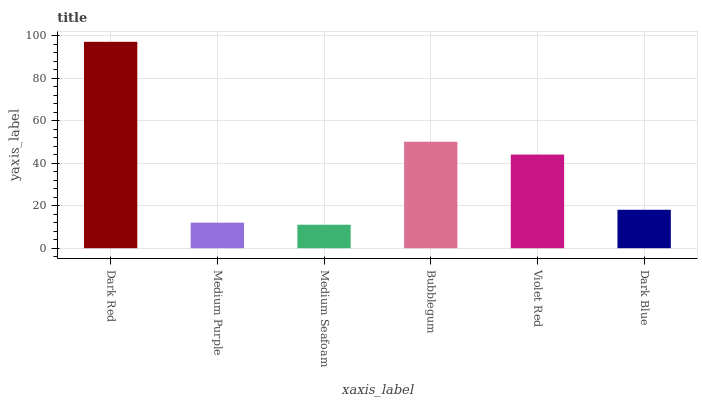Is Medium Purple the minimum?
Answer yes or no. No. Is Medium Purple the maximum?
Answer yes or no. No. Is Dark Red greater than Medium Purple?
Answer yes or no. Yes. Is Medium Purple less than Dark Red?
Answer yes or no. Yes. Is Medium Purple greater than Dark Red?
Answer yes or no. No. Is Dark Red less than Medium Purple?
Answer yes or no. No. Is Violet Red the high median?
Answer yes or no. Yes. Is Dark Blue the low median?
Answer yes or no. Yes. Is Bubblegum the high median?
Answer yes or no. No. Is Violet Red the low median?
Answer yes or no. No. 